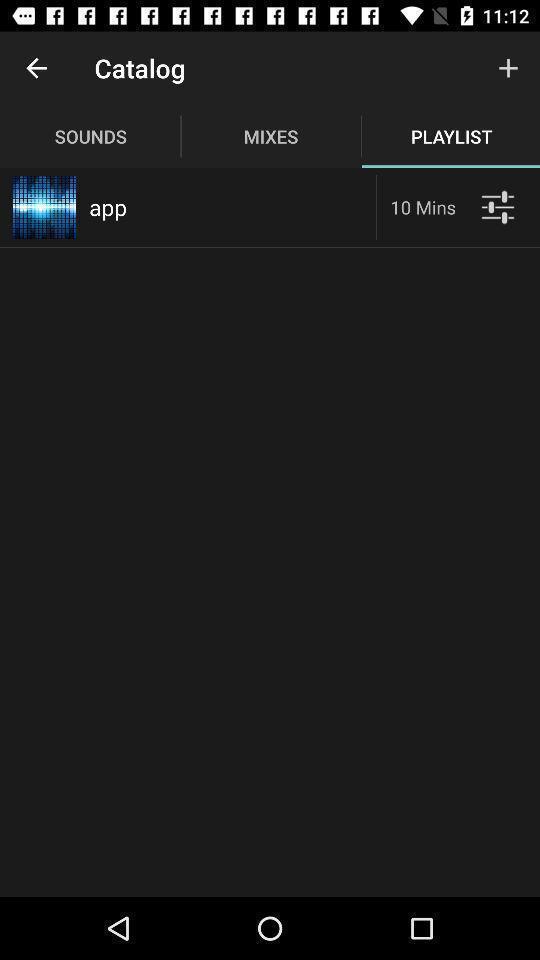Give me a summary of this screen capture. Page showing different songs available. 